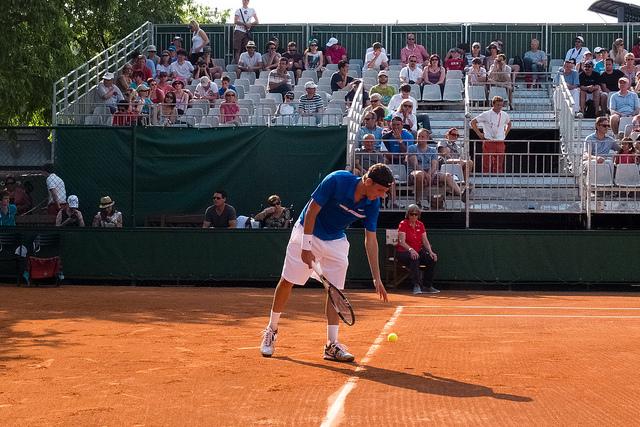Is the ball in motion?
Concise answer only. Yes. What color are the man's shorts?
Short answer required. White. Is this court grass?
Answer briefly. No. 